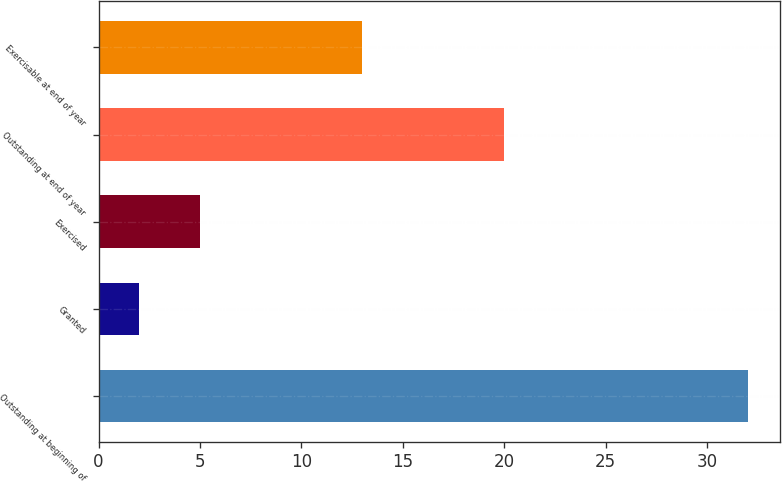<chart> <loc_0><loc_0><loc_500><loc_500><bar_chart><fcel>Outstanding at beginning of<fcel>Granted<fcel>Exercised<fcel>Outstanding at end of year<fcel>Exercisable at end of year<nl><fcel>32<fcel>2<fcel>5<fcel>20<fcel>13<nl></chart> 